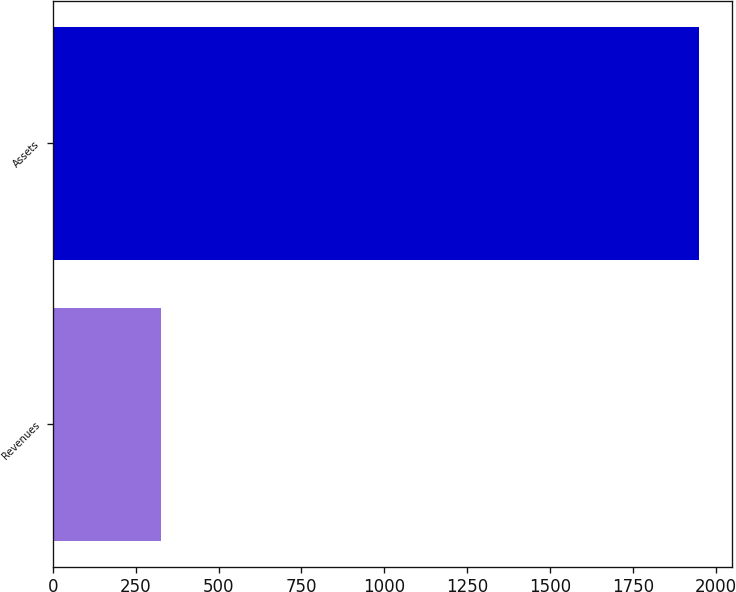Convert chart. <chart><loc_0><loc_0><loc_500><loc_500><bar_chart><fcel>Revenues<fcel>Assets<nl><fcel>326.6<fcel>1950.5<nl></chart> 